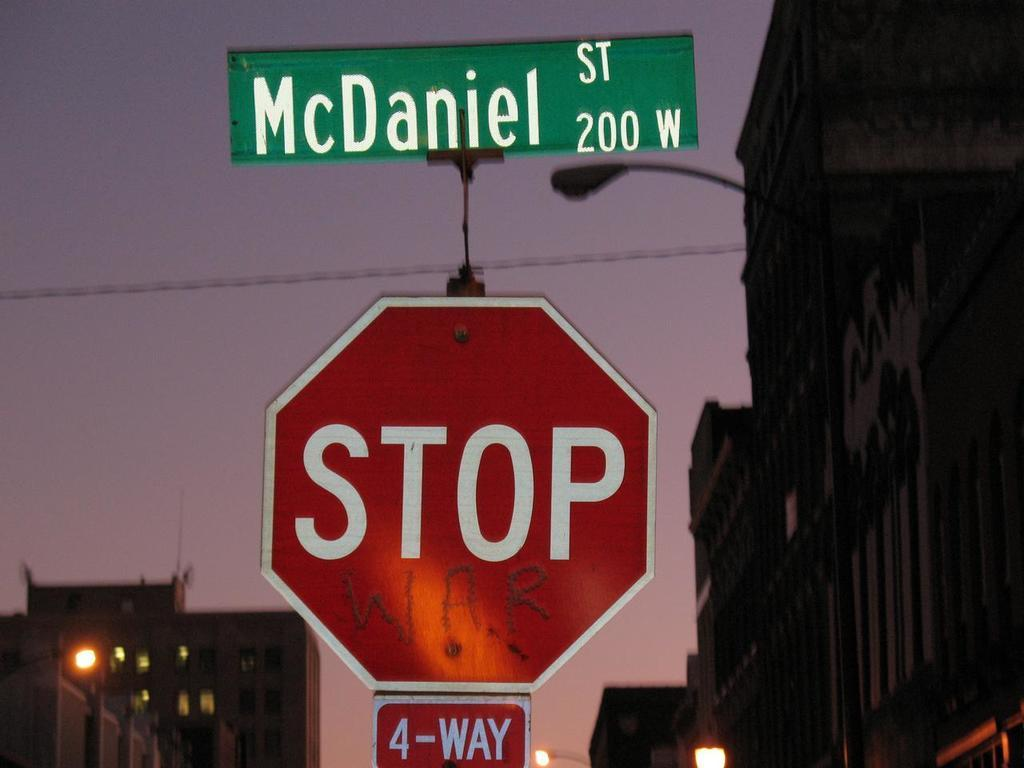<image>
Write a terse but informative summary of the picture. a stop sign with Daniel street shown above 